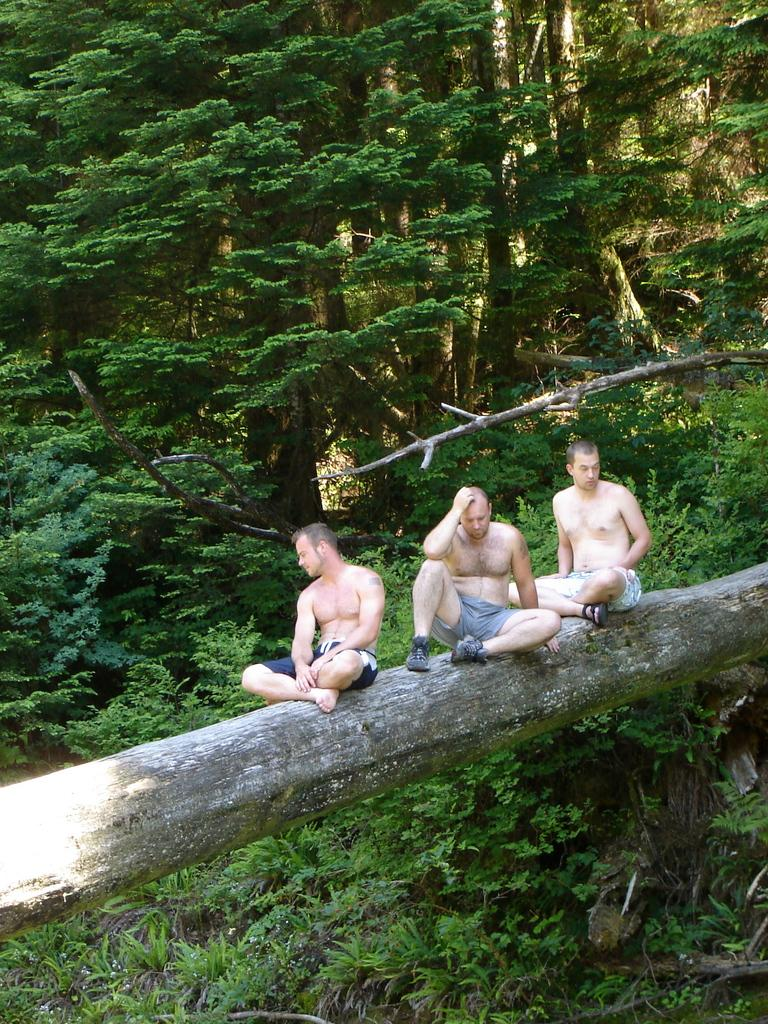What is the main subject in the middle of the image? There is a tree trunk in the middle of the image. What are the three persons doing in the image? The three persons are sitting on the tree trunk. What type of vegetation is present at the bottom of the image? There are plants at the bottom of the image. What can be seen in the background of the image? There are trees in the background of the image. Can you see a snake slithering through space in the image? There is no snake or space present in the image; it features a tree trunk, three persons sitting on it, plants at the bottom, and trees in the background. 